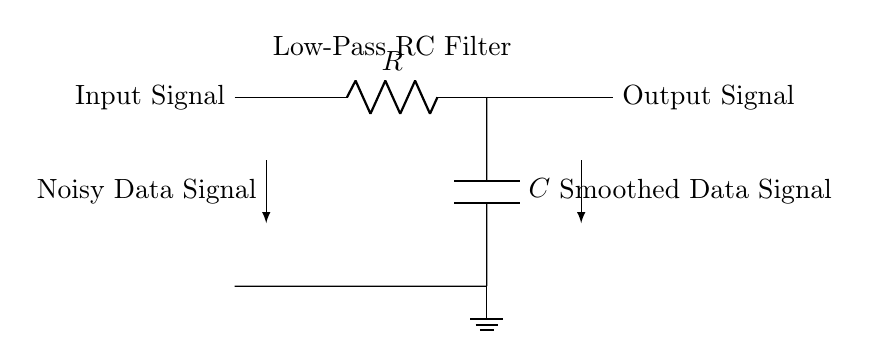What type of filter is depicted in this circuit? The circuit diagram shows an RC low-pass filter which allows low-frequency signals to pass while attenuating higher frequency signals. This is indicated by the labeling "Low-Pass RC Filter."
Answer: Low-pass filter What is the role of the resistor in this circuit? The resistor limits the rate of charging and discharging of the capacitor, impacting the time constant of the filter. It works together with the capacitor to determine the cutoff frequency.
Answer: Limit current What is connected to the output of the circuit? The output of the circuit is connected to the "Output Signal" terminal, which represents the smoothed data signal resulting from the filtering process.
Answer: Smoothed data signal What does the ground symbol represent in this circuit? The ground symbol denotes a reference point in the circuit, where the voltage is defined as zero. It provides a common return path for current and helps stabilize the circuit.
Answer: Reference point How does the capacitor influence the circuit's behavior? The capacitor stores and releases energy, which smooths out fluctuations in the input signal; it charges slowly during high-frequency signals and discharges during low-frequency signals, contributing to the filtering effect.
Answer: Smooth fluctuations What does the input signal represent in the context of user interaction analysis? The input signal represents the noisy data signal received from user interactions, which the RC low-pass filter is intended to clean up and smooth out.
Answer: Noisy data signal What is the cutoff frequency formula for this RC filter? The cutoff frequency in an RC filter is given by the formula f_c = 1 / (2πRC), where R is the resistance and C is the capacitance; it defines the frequency at which the output signal is reduced to 70.7% of the input signal.
Answer: f_c = 1/(2πRC) 